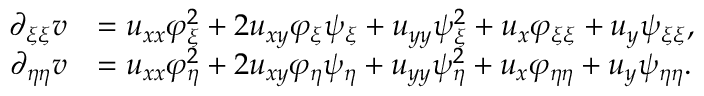Convert formula to latex. <formula><loc_0><loc_0><loc_500><loc_500>\begin{array} { r l } { \partial _ { \xi \xi } v } & { = u _ { x x } \varphi _ { \xi } ^ { 2 } + 2 u _ { x y } \varphi _ { \xi } \psi _ { \xi } + u _ { y y } \psi _ { \xi } ^ { 2 } + u _ { x } \varphi _ { \xi \xi } + u _ { y } \psi _ { \xi \xi } , } \\ { \partial _ { \eta \eta } v } & { = u _ { x x } \varphi _ { \eta } ^ { 2 } + 2 u _ { x y } \varphi _ { \eta } \psi _ { \eta } + u _ { y y } \psi _ { \eta } ^ { 2 } + u _ { x } \varphi _ { \eta \eta } + u _ { y } \psi _ { \eta \eta } . } \end{array}</formula> 